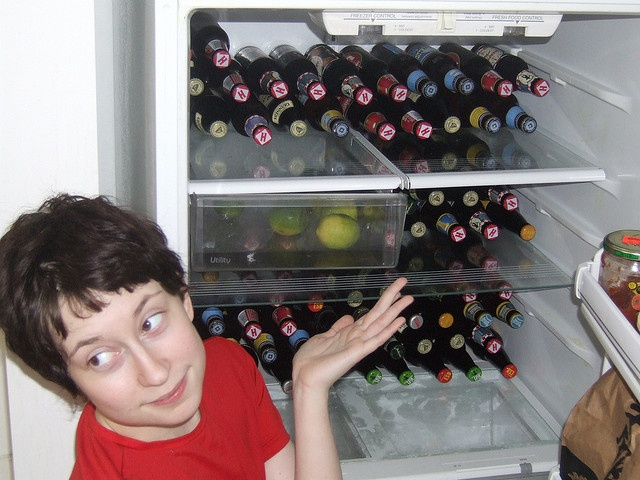Describe the objects in this image and their specific colors. I can see refrigerator in white, black, darkgray, gray, and lightgray tones, people in white, black, tan, brown, and darkgray tones, bottle in white, black, gray, and olive tones, bottle in white, black, gray, darkgray, and maroon tones, and bottle in white, black, gray, and darkgray tones in this image. 